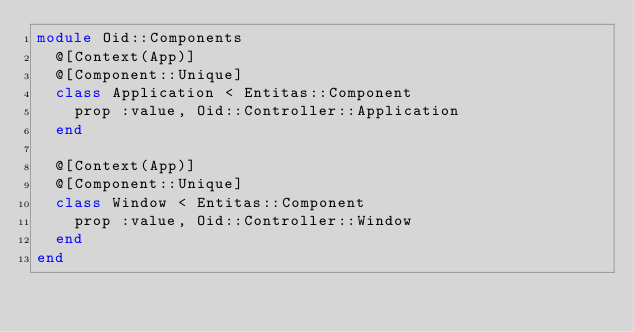Convert code to text. <code><loc_0><loc_0><loc_500><loc_500><_Crystal_>module Oid::Components
  @[Context(App)]
  @[Component::Unique]
  class Application < Entitas::Component
    prop :value, Oid::Controller::Application
  end

  @[Context(App)]
  @[Component::Unique]
  class Window < Entitas::Component
    prop :value, Oid::Controller::Window
  end
end
</code> 